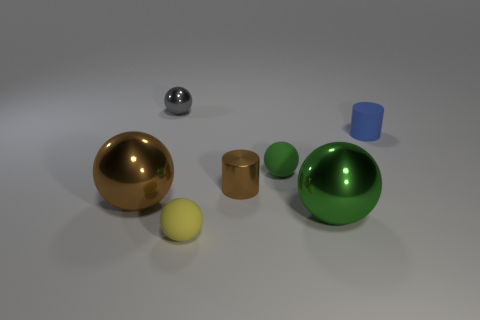There is a green ball that is the same material as the blue cylinder; what is its size?
Your answer should be compact. Small. How many big things have the same color as the tiny shiny cylinder?
Ensure brevity in your answer.  1. Is the number of yellow matte objects that are left of the yellow matte object less than the number of small blue cylinders on the right side of the gray sphere?
Provide a succinct answer. Yes. Is the shape of the brown thing that is right of the yellow rubber sphere the same as  the gray metallic thing?
Your answer should be very brief. No. Is there anything else that is the same material as the tiny brown cylinder?
Provide a succinct answer. Yes. Is the material of the big object left of the small green thing the same as the tiny yellow thing?
Give a very brief answer. No. What is the material of the small cylinder that is on the right side of the brown thing that is on the right side of the gray thing behind the brown shiny cylinder?
Make the answer very short. Rubber. What number of other objects are there of the same shape as the large green shiny thing?
Keep it short and to the point. 4. There is a thing left of the tiny gray ball; what is its color?
Your answer should be compact. Brown. What number of large metal things are in front of the metal ball on the right side of the metallic object behind the tiny blue matte cylinder?
Make the answer very short. 0. 